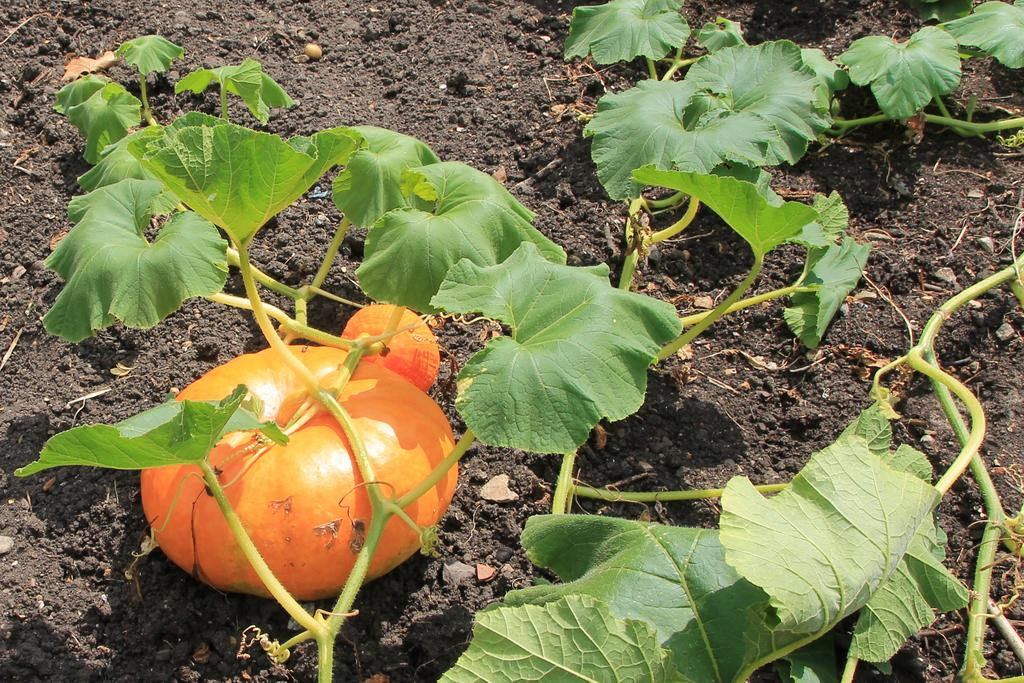What is the main element in the picture? There is mud in the picture. What can be found within the mud? There are plants in the mud. Where is the pumpkin located in the picture? The pumpkin is on the left bottom of the picture. What type of scissors can be seen cutting the plants in the picture? There are no scissors present in the picture; it only shows mud, plants, and a pumpkin. 